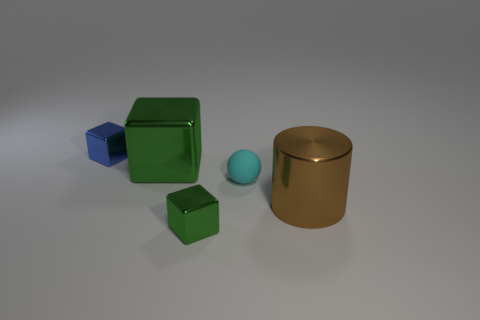What number of blue things have the same material as the big green thing?
Your answer should be compact. 1. What is the shape of the small object that is the same color as the big metal block?
Offer a terse response. Cube. What material is the small thing that is both behind the small green shiny thing and on the right side of the big green thing?
Give a very brief answer. Rubber. What is the shape of the small object behind the small cyan rubber thing?
Ensure brevity in your answer.  Cube. There is a large shiny thing right of the tiny cyan matte ball behind the big brown metal cylinder; what is its shape?
Provide a succinct answer. Cylinder. Is there a green metal thing of the same shape as the tiny blue thing?
Offer a terse response. Yes. What shape is the blue object that is the same size as the rubber sphere?
Your response must be concise. Cube. There is a tiny object to the left of the block that is to the right of the large green metallic object; are there any blocks that are left of it?
Offer a very short reply. No. Are there any blue metal balls that have the same size as the cyan matte thing?
Your answer should be compact. No. What size is the cyan object in front of the blue thing?
Your answer should be very brief. Small. 